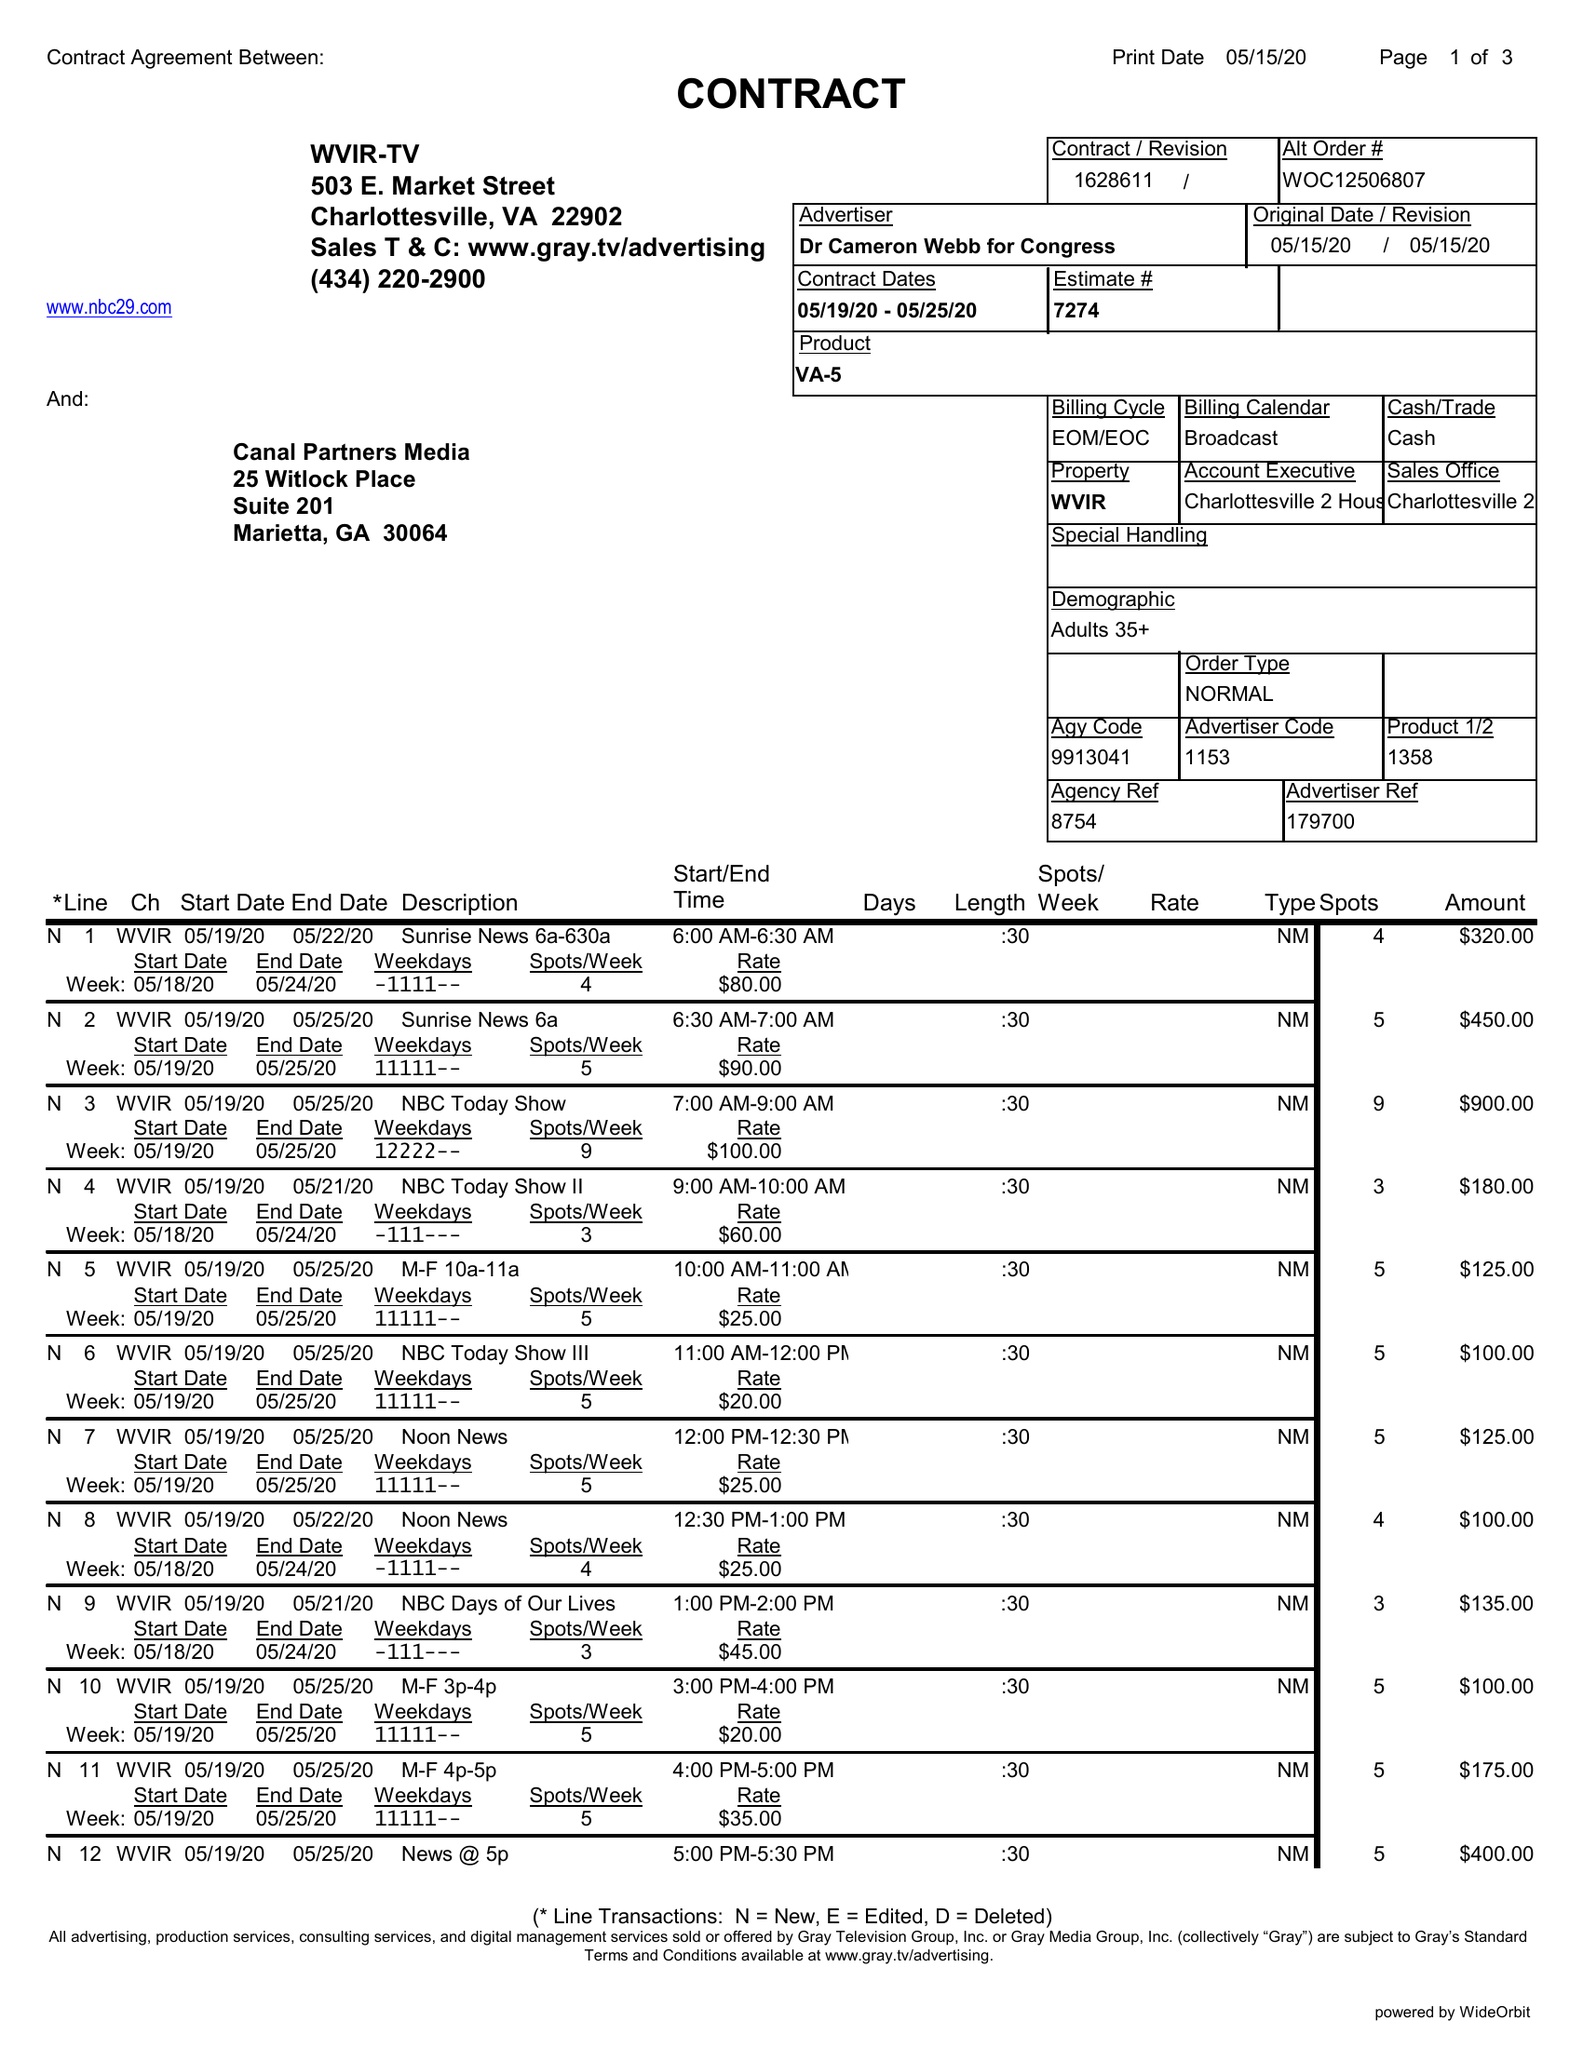What is the value for the contract_num?
Answer the question using a single word or phrase. 1628611 